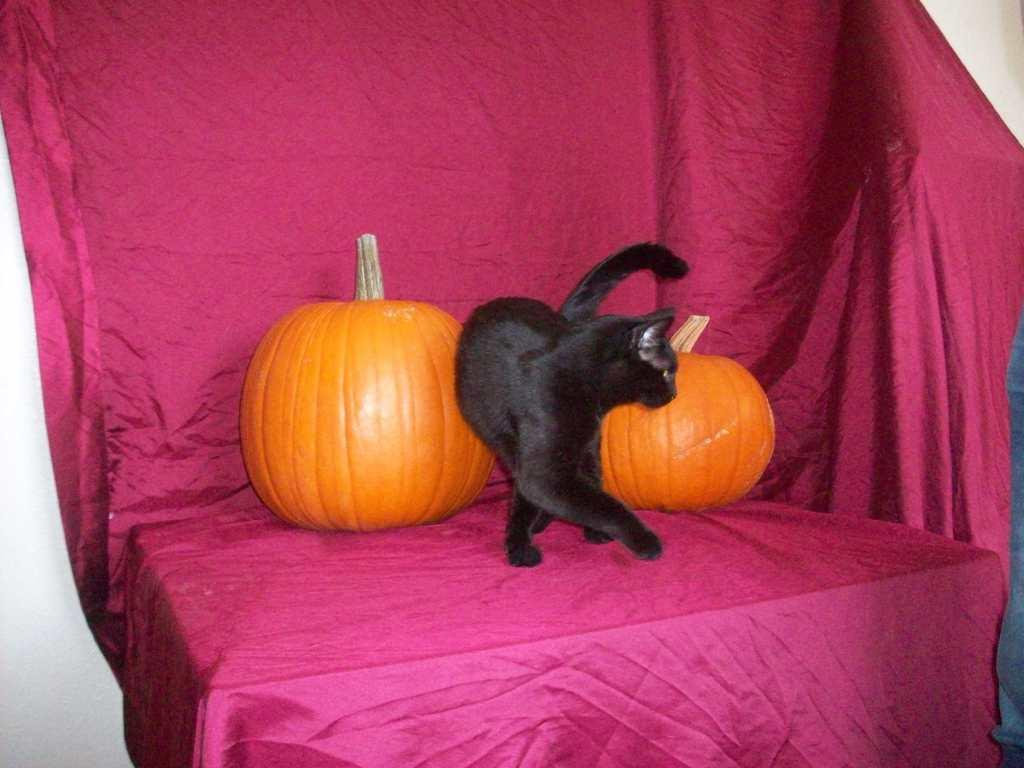What type of furniture is present in the image? There is a table in the image. What is covering the table? There is a cloth on the table. What objects are placed on the table? There are pumpkins on the table. Are there any animals visible in the image? Yes, there is a cat in the image. What type of grip does the cat have on the sidewalk in the image? There is no sidewalk present in the image, and the cat is not gripping anything. 